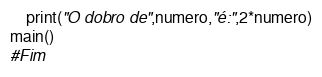<code> <loc_0><loc_0><loc_500><loc_500><_Python_>    print("O dobro de",numero,"é:",2*numero)
main()    
#Fim</code> 